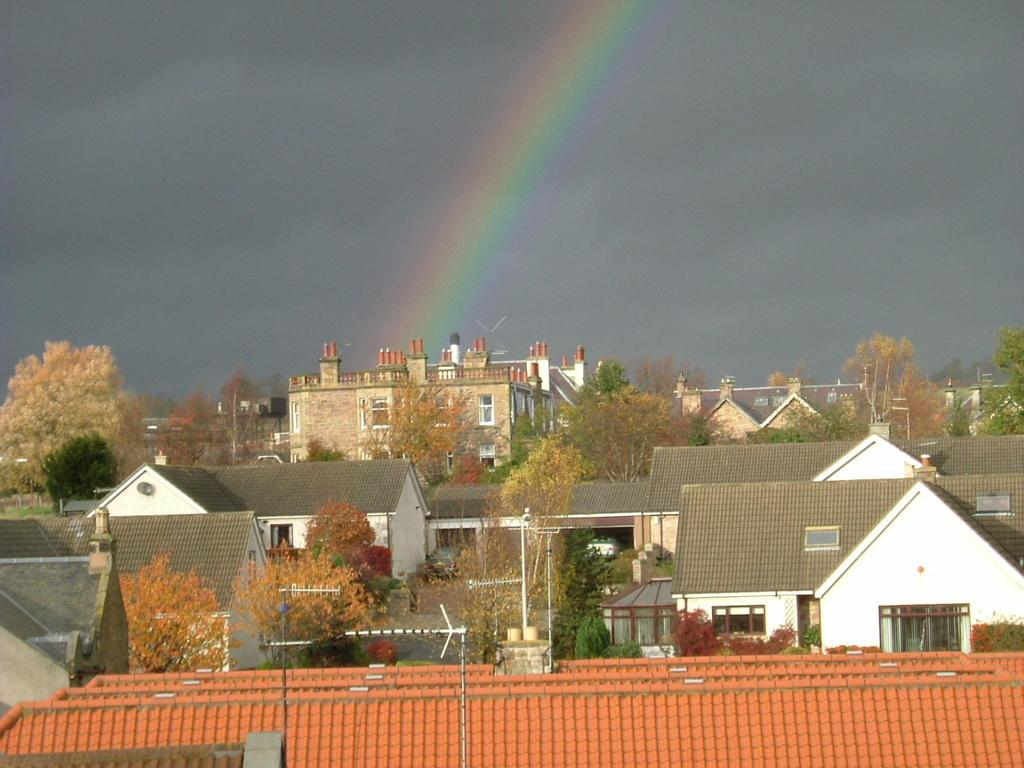What type of structures can be seen in the image? There are buildings in the image. What other natural elements are present in the image? There are trees in the image. What are the tall, thin objects in the image? There are poles in the image. What can be seen on the top of the buildings? There are roof tiles on the top of the buildings. What is visible at the top of the image? The sky is visible at the top of the image. What additional feature can be seen in the sky? There is a rainbow in the sky. How many cherries are hanging from the roof tiles in the image? There are no cherries present in the image; it features buildings, trees, poles, roof tiles, and a rainbow in the sky. What type of property is being sold in the image? There is no indication of any property being sold in the image. 